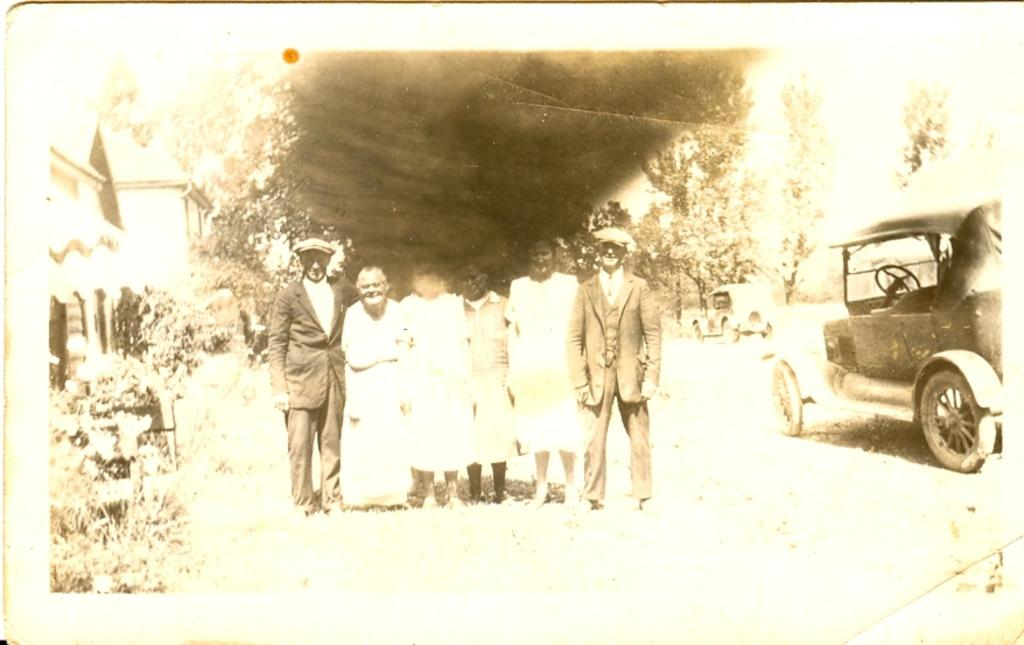What type of object is depicted in the old picture in the image? The information provided does not specify the content of the old picture. What kind of vehicles can be seen in the image? There are vehicles in the image, but the specific types are not mentioned. How many people are present in the image? The number of people in the image is not specified. What kind of plants are in the image? The information provided does not specify the type of plants. What is the architectural style of the house in the image? The information provided does not describe the house's architectural style. What type of trees are in the image? The information provided does not specify the type of trees. What type of cloth is being used to cover the hole in the image? There is no mention of a hole or cloth in the image. 